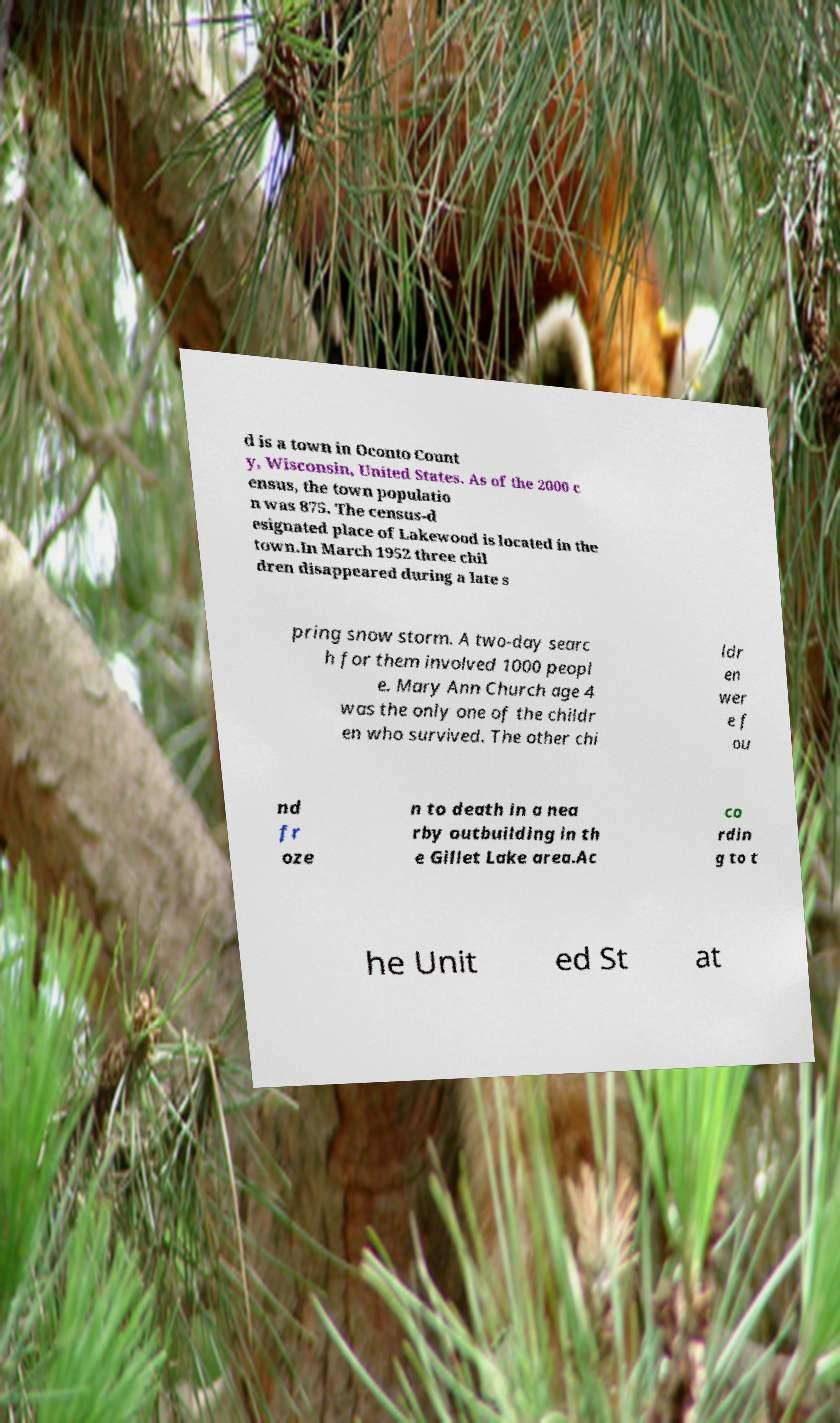Please identify and transcribe the text found in this image. d is a town in Oconto Count y, Wisconsin, United States. As of the 2000 c ensus, the town populatio n was 875. The census-d esignated place of Lakewood is located in the town.In March 1952 three chil dren disappeared during a late s pring snow storm. A two-day searc h for them involved 1000 peopl e. Mary Ann Church age 4 was the only one of the childr en who survived. The other chi ldr en wer e f ou nd fr oze n to death in a nea rby outbuilding in th e Gillet Lake area.Ac co rdin g to t he Unit ed St at 